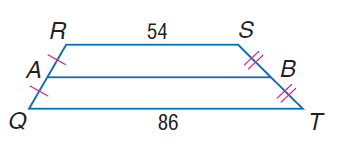Answer the mathemtical geometry problem and directly provide the correct option letter.
Question: Let J K be the median of A B T Q. Find J K.
Choices: A: 43 B: 54 C: 78 D: 86 C 